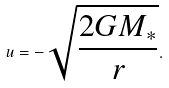Convert formula to latex. <formula><loc_0><loc_0><loc_500><loc_500>u = - \sqrt { \frac { 2 G M _ { \ast } } { r } } .</formula> 